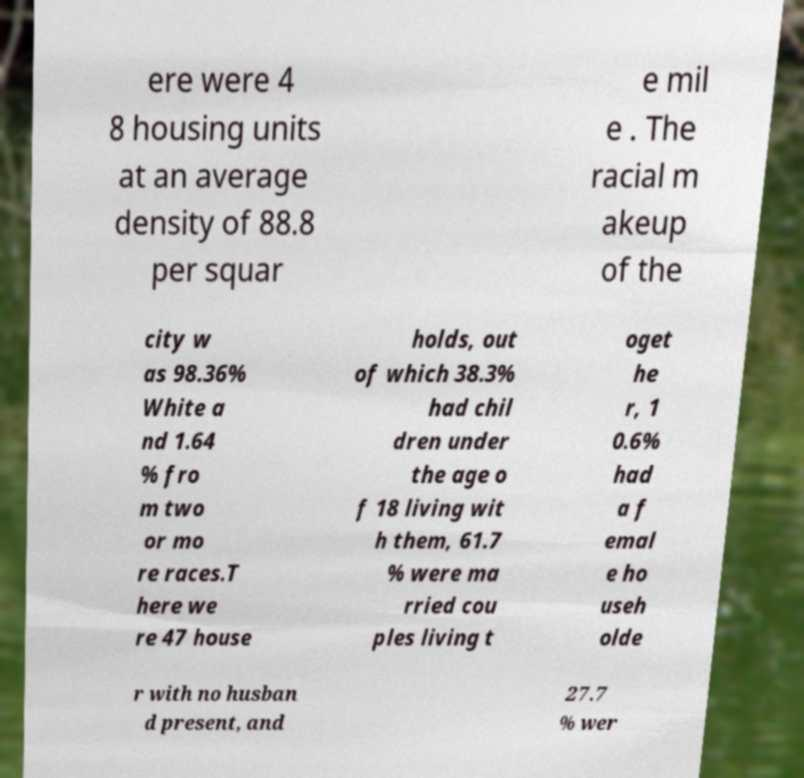Please identify and transcribe the text found in this image. ere were 4 8 housing units at an average density of 88.8 per squar e mil e . The racial m akeup of the city w as 98.36% White a nd 1.64 % fro m two or mo re races.T here we re 47 house holds, out of which 38.3% had chil dren under the age o f 18 living wit h them, 61.7 % were ma rried cou ples living t oget he r, 1 0.6% had a f emal e ho useh olde r with no husban d present, and 27.7 % wer 